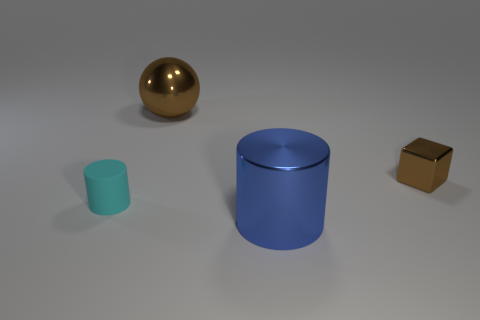Does the large object that is on the left side of the big blue metallic cylinder have the same color as the cylinder that is on the left side of the large brown object?
Offer a terse response. No. Are there any big brown spheres that have the same material as the small brown block?
Offer a terse response. Yes. How big is the brown metal thing left of the thing right of the metallic cylinder?
Make the answer very short. Large. Are there more small brown things than purple cubes?
Ensure brevity in your answer.  Yes. Do the brown metallic object on the left side of the blue metal cylinder and the tiny rubber thing have the same size?
Make the answer very short. No. What number of tiny metallic blocks are the same color as the large metallic sphere?
Your answer should be very brief. 1. Do the cyan rubber thing and the small brown thing have the same shape?
Provide a short and direct response. No. There is a blue metal thing that is the same shape as the small cyan rubber thing; what size is it?
Provide a short and direct response. Large. Is the number of brown things that are on the left side of the blue object greater than the number of rubber things right of the ball?
Make the answer very short. Yes. Is the material of the tiny brown block the same as the small cylinder that is behind the large metallic cylinder?
Ensure brevity in your answer.  No. 